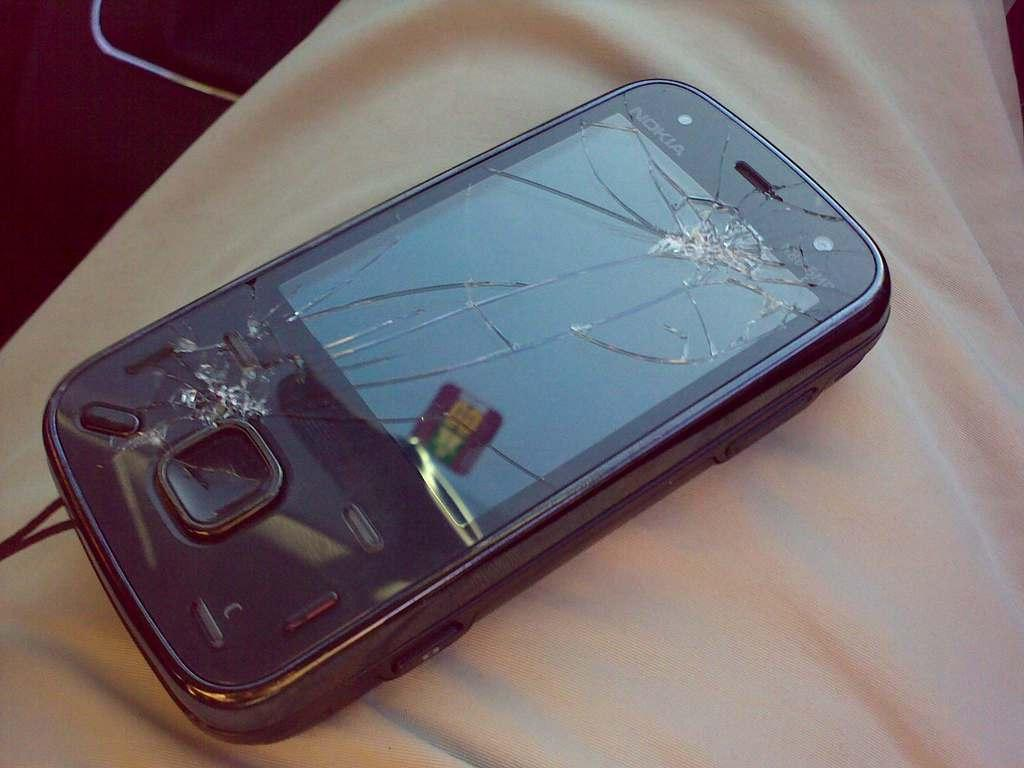What is the main subject of the image? The main subject of the image is a broken mobile screen. What is the condition of the mobile screen? The mobile screen is broken. What is the broken mobile screen placed on? The broken mobile screen is on a cloth. Can you see any matches or a plough in the image? There are no matches or plough visible in the image. How many ants are crawling on the broken mobile screen in the image? There are no ants present on the broken mobile screen in the image. 